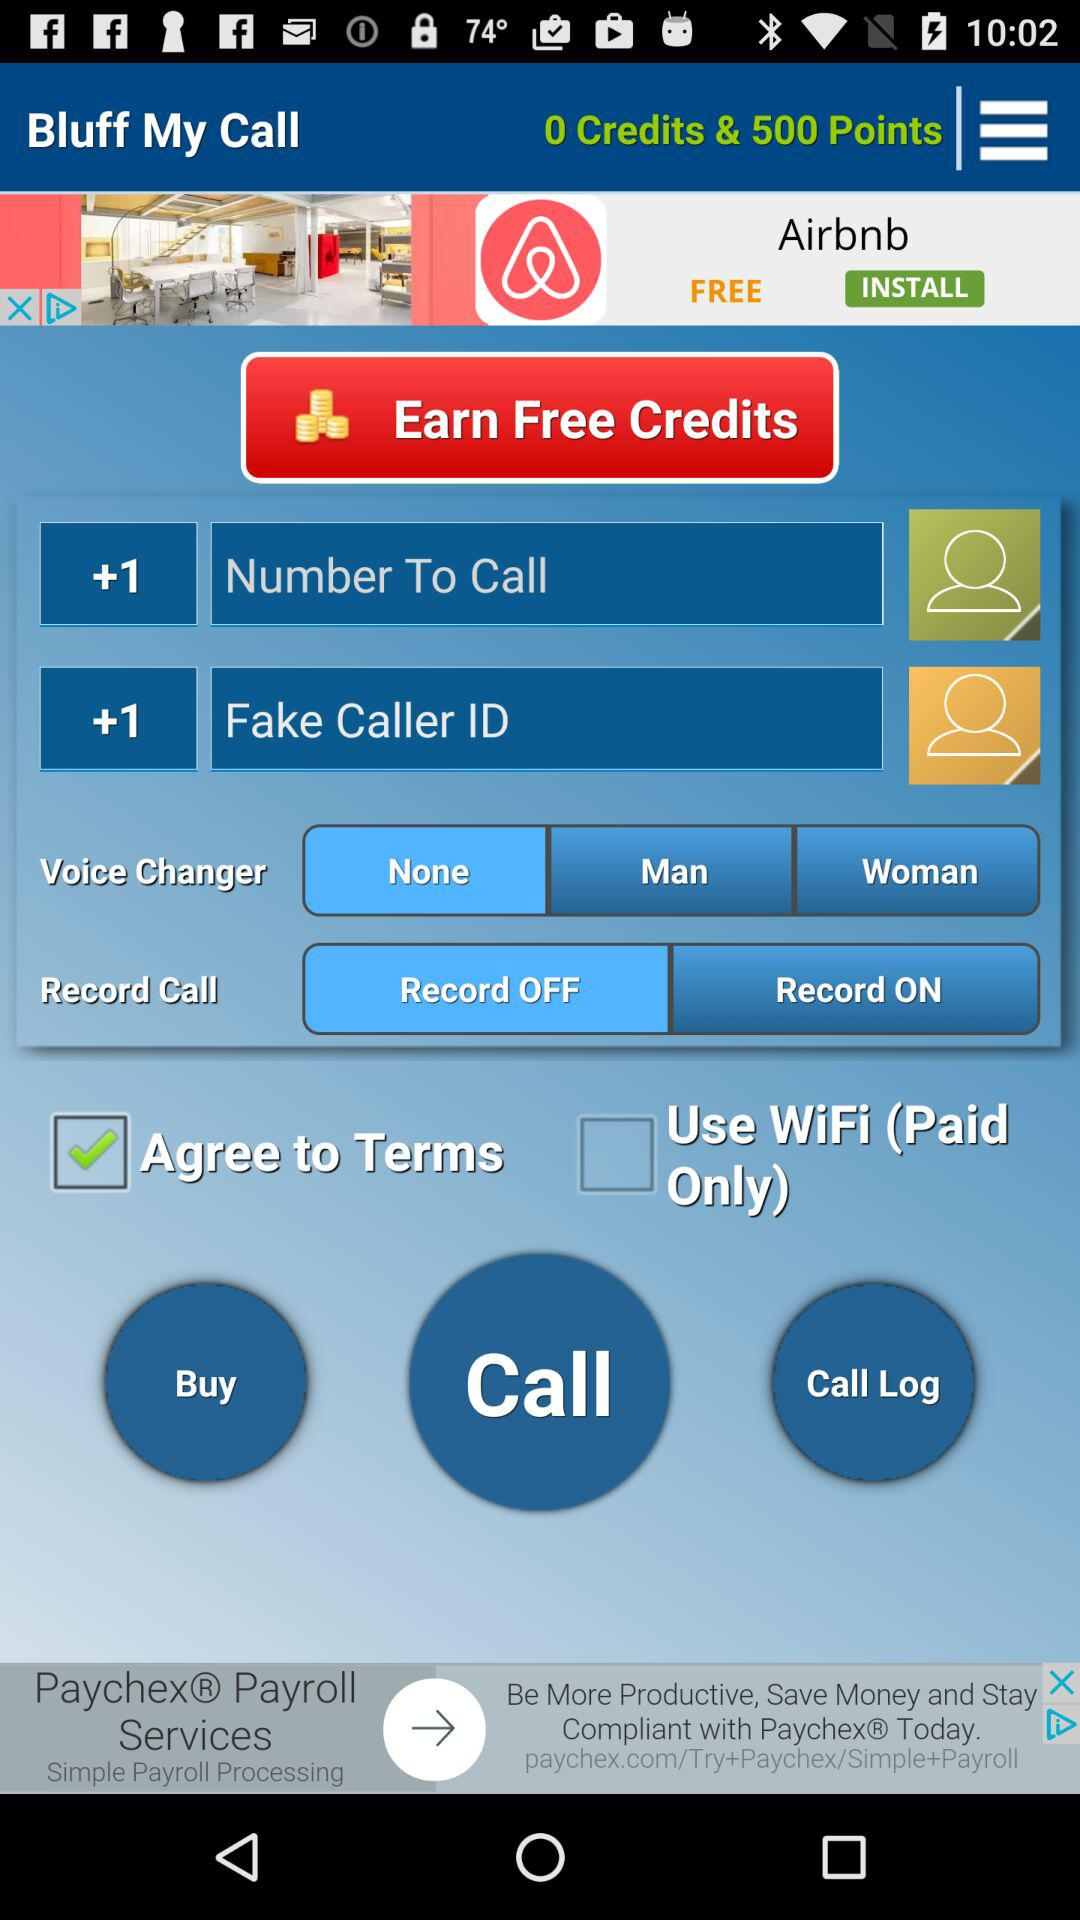How many points are there? There are 500 points. 